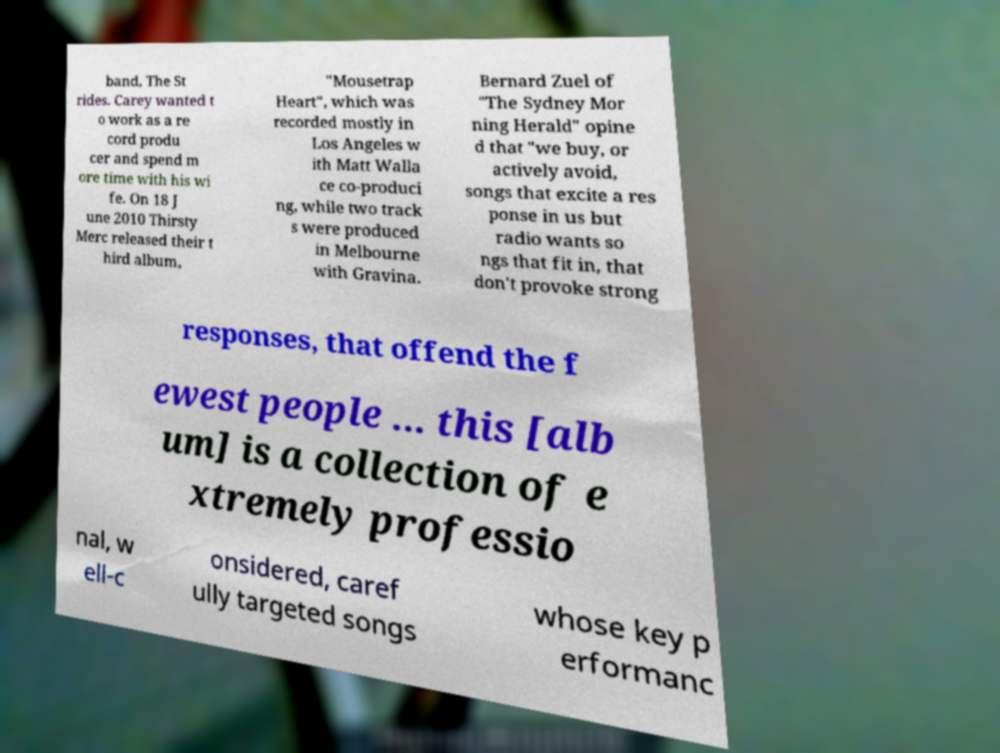Please identify and transcribe the text found in this image. band, The St rides. Carey wanted t o work as a re cord produ cer and spend m ore time with his wi fe. On 18 J une 2010 Thirsty Merc released their t hird album, "Mousetrap Heart", which was recorded mostly in Los Angeles w ith Matt Walla ce co-produci ng, while two track s were produced in Melbourne with Gravina. Bernard Zuel of "The Sydney Mor ning Herald" opine d that "we buy, or actively avoid, songs that excite a res ponse in us but radio wants so ngs that fit in, that don't provoke strong responses, that offend the f ewest people ... this [alb um] is a collection of e xtremely professio nal, w ell-c onsidered, caref ully targeted songs whose key p erformanc 